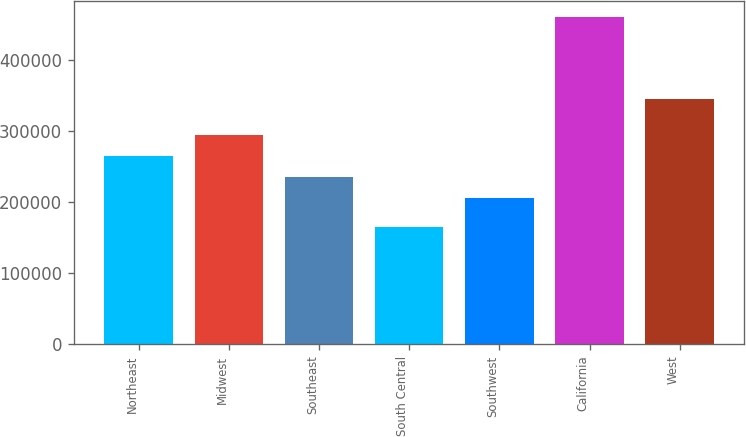Convert chart. <chart><loc_0><loc_0><loc_500><loc_500><bar_chart><fcel>Northeast<fcel>Midwest<fcel>Southeast<fcel>South Central<fcel>Southwest<fcel>California<fcel>West<nl><fcel>265580<fcel>295120<fcel>236040<fcel>165200<fcel>206500<fcel>460600<fcel>345300<nl></chart> 